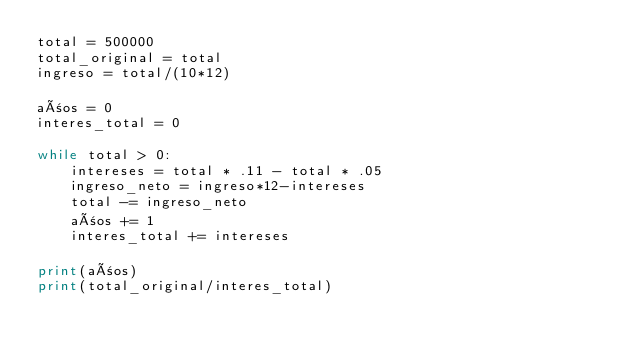<code> <loc_0><loc_0><loc_500><loc_500><_Python_>total = 500000
total_original = total
ingreso = total/(10*12)

años = 0
interes_total = 0

while total > 0:
    intereses = total * .11 - total * .05
    ingreso_neto = ingreso*12-intereses
    total -= ingreso_neto
    años += 1
    interes_total += intereses

print(años)
print(total_original/interes_total)</code> 